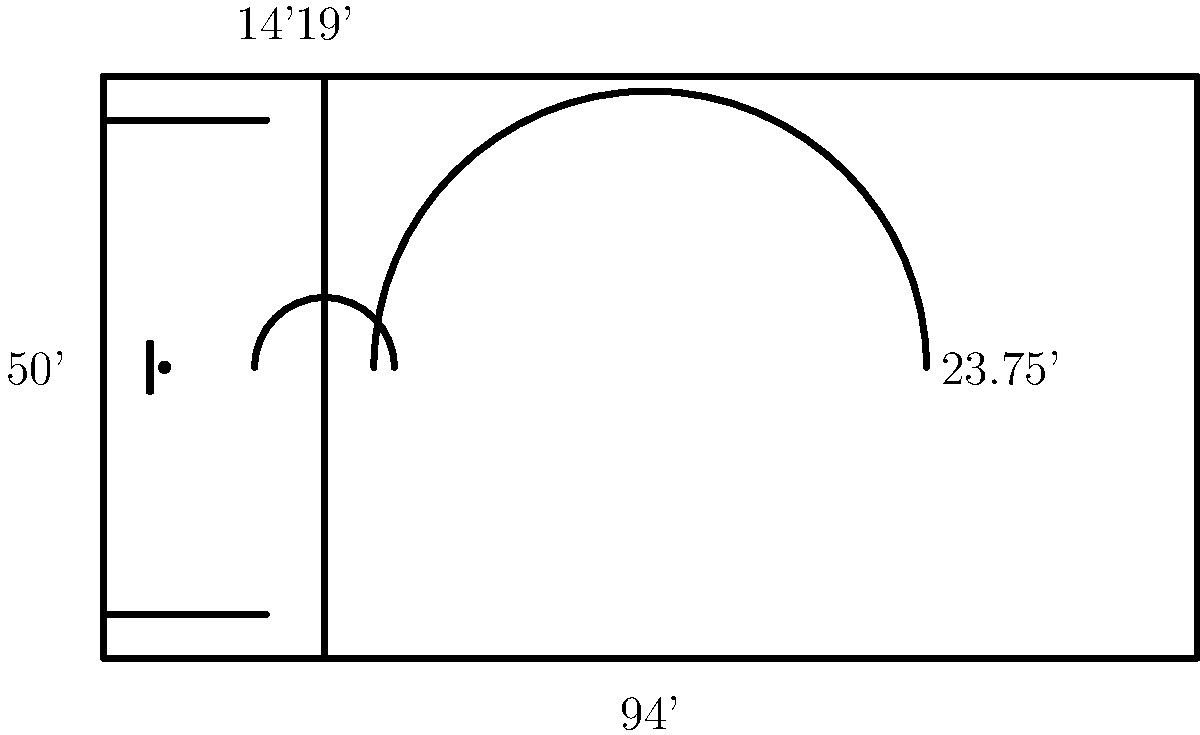As a basketball coach, you're designing a drill that utilizes the three-point line. If a player starts at the center of the free throw line and runs to the three-point line perpendicular to the baseline, what is the shortest distance they would need to cover? Round your answer to the nearest inch. Let's approach this step-by-step:

1) First, we need to identify the key measurements from the diagram:
   - The free throw line is 19 feet from the baseline
   - The three-point line is an arc with a radius of 23.75 feet from the center of the basket

2) The center of the basket is 5.25 feet from the baseline (not directly given, but standard knowledge for a coach).

3) To find the distance from the free throw line to the three-point line, we need to:
   a) Calculate the distance from the baseline to where the perpendicular line from the free throw line meets the three-point line
   b) Subtract the distance of the free throw line from the baseline

4) The distance we're looking for can be found using the Pythagorean theorem:
   $$(23.75)^2 = x^2 + (23.75 - 5.25)^2$$
   where $x$ is the distance from the baseline to where our perpendicular line meets the three-point line

5) Simplifying:
   $$(23.75)^2 = x^2 + (18.5)^2$$
   $$564.0625 = x^2 + 342.25$$
   $$x^2 = 221.8125$$
   $$x = \sqrt{221.8125} \approx 14.8933$$

6) The distance from the free throw line to this point is:
   $$14.8933 - 19 = -4.1067$$ feet

7) Converting to inches:
   $$|-4.1067| \times 12 \approx 49.2804$$ inches

8) Rounding to the nearest inch: 49 inches
Answer: 49 inches 